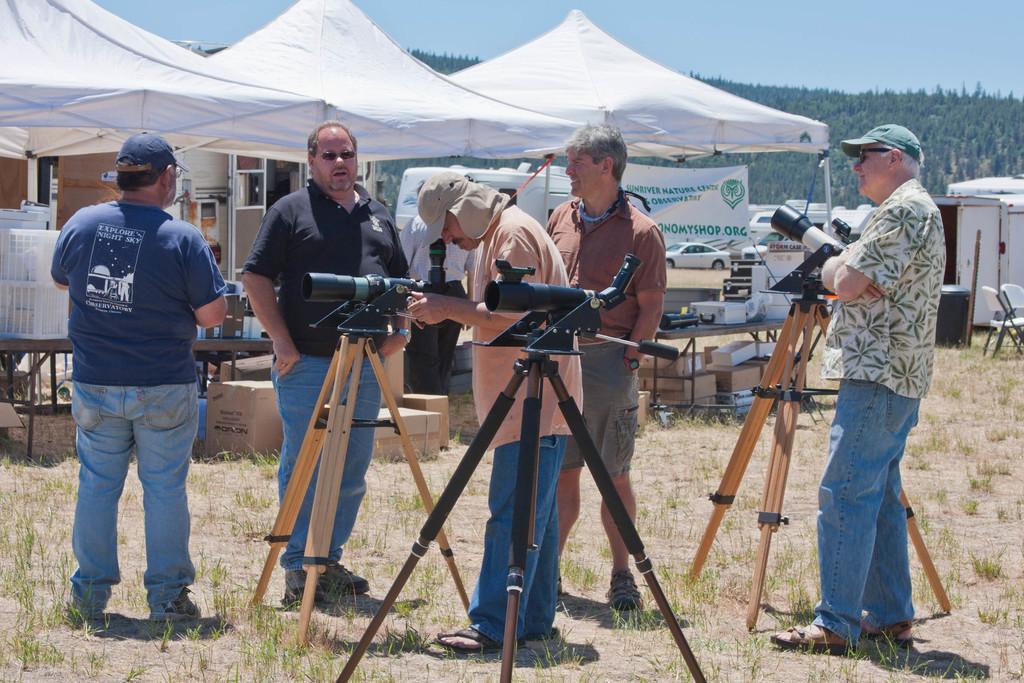In one or two sentences, can you explain what this image depicts? In this picture I can see a group of men are standing on the ground. Here I can see some objects on the ground. In the background I can see white color text, boxes, tables and other objects. On the right side I can see a chair, vehicles and some other objects. In the background I can see trees and the sky. 